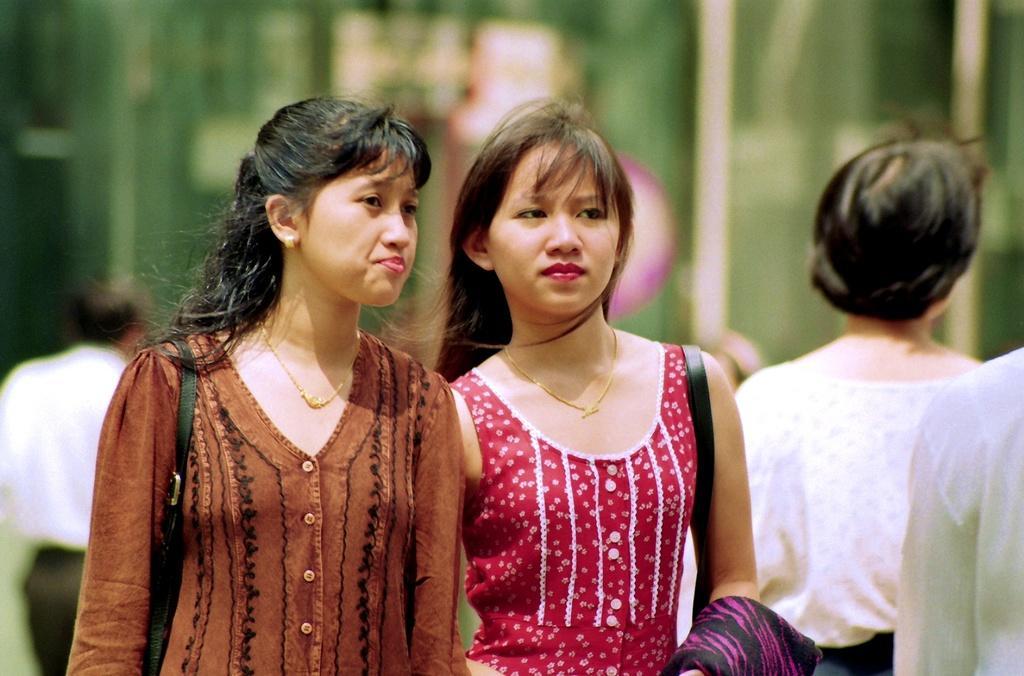Please provide a concise description of this image. In this picture we can see chains, straps, cloth, two women and at the back of them we can see some people and in the background we can see some objects and it is blurry. 